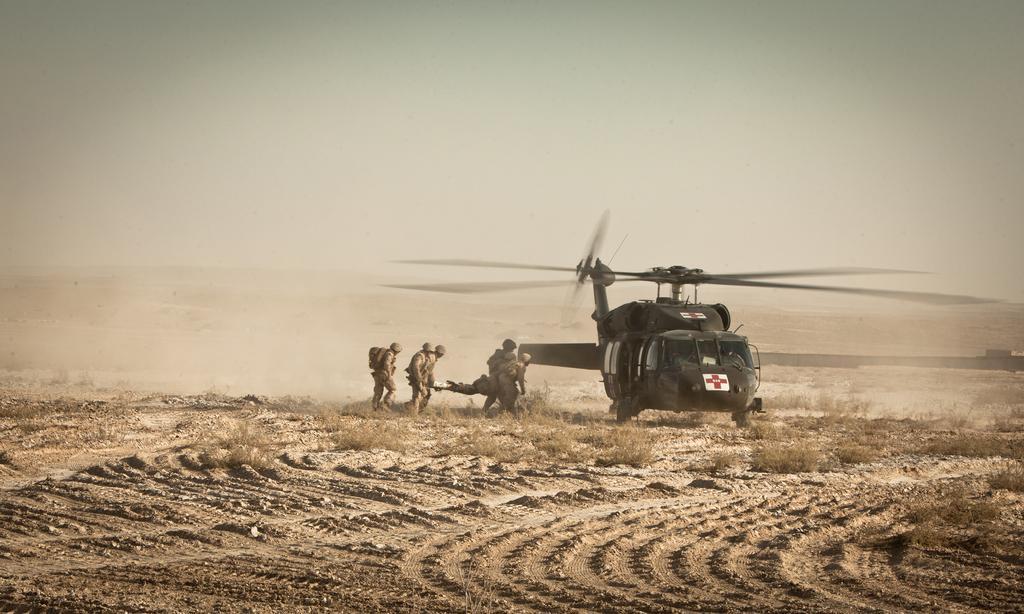Could you give a brief overview of what you see in this image? This is the picture of a plane which is black in color and around there are some people and some sand and stones on the floor. 